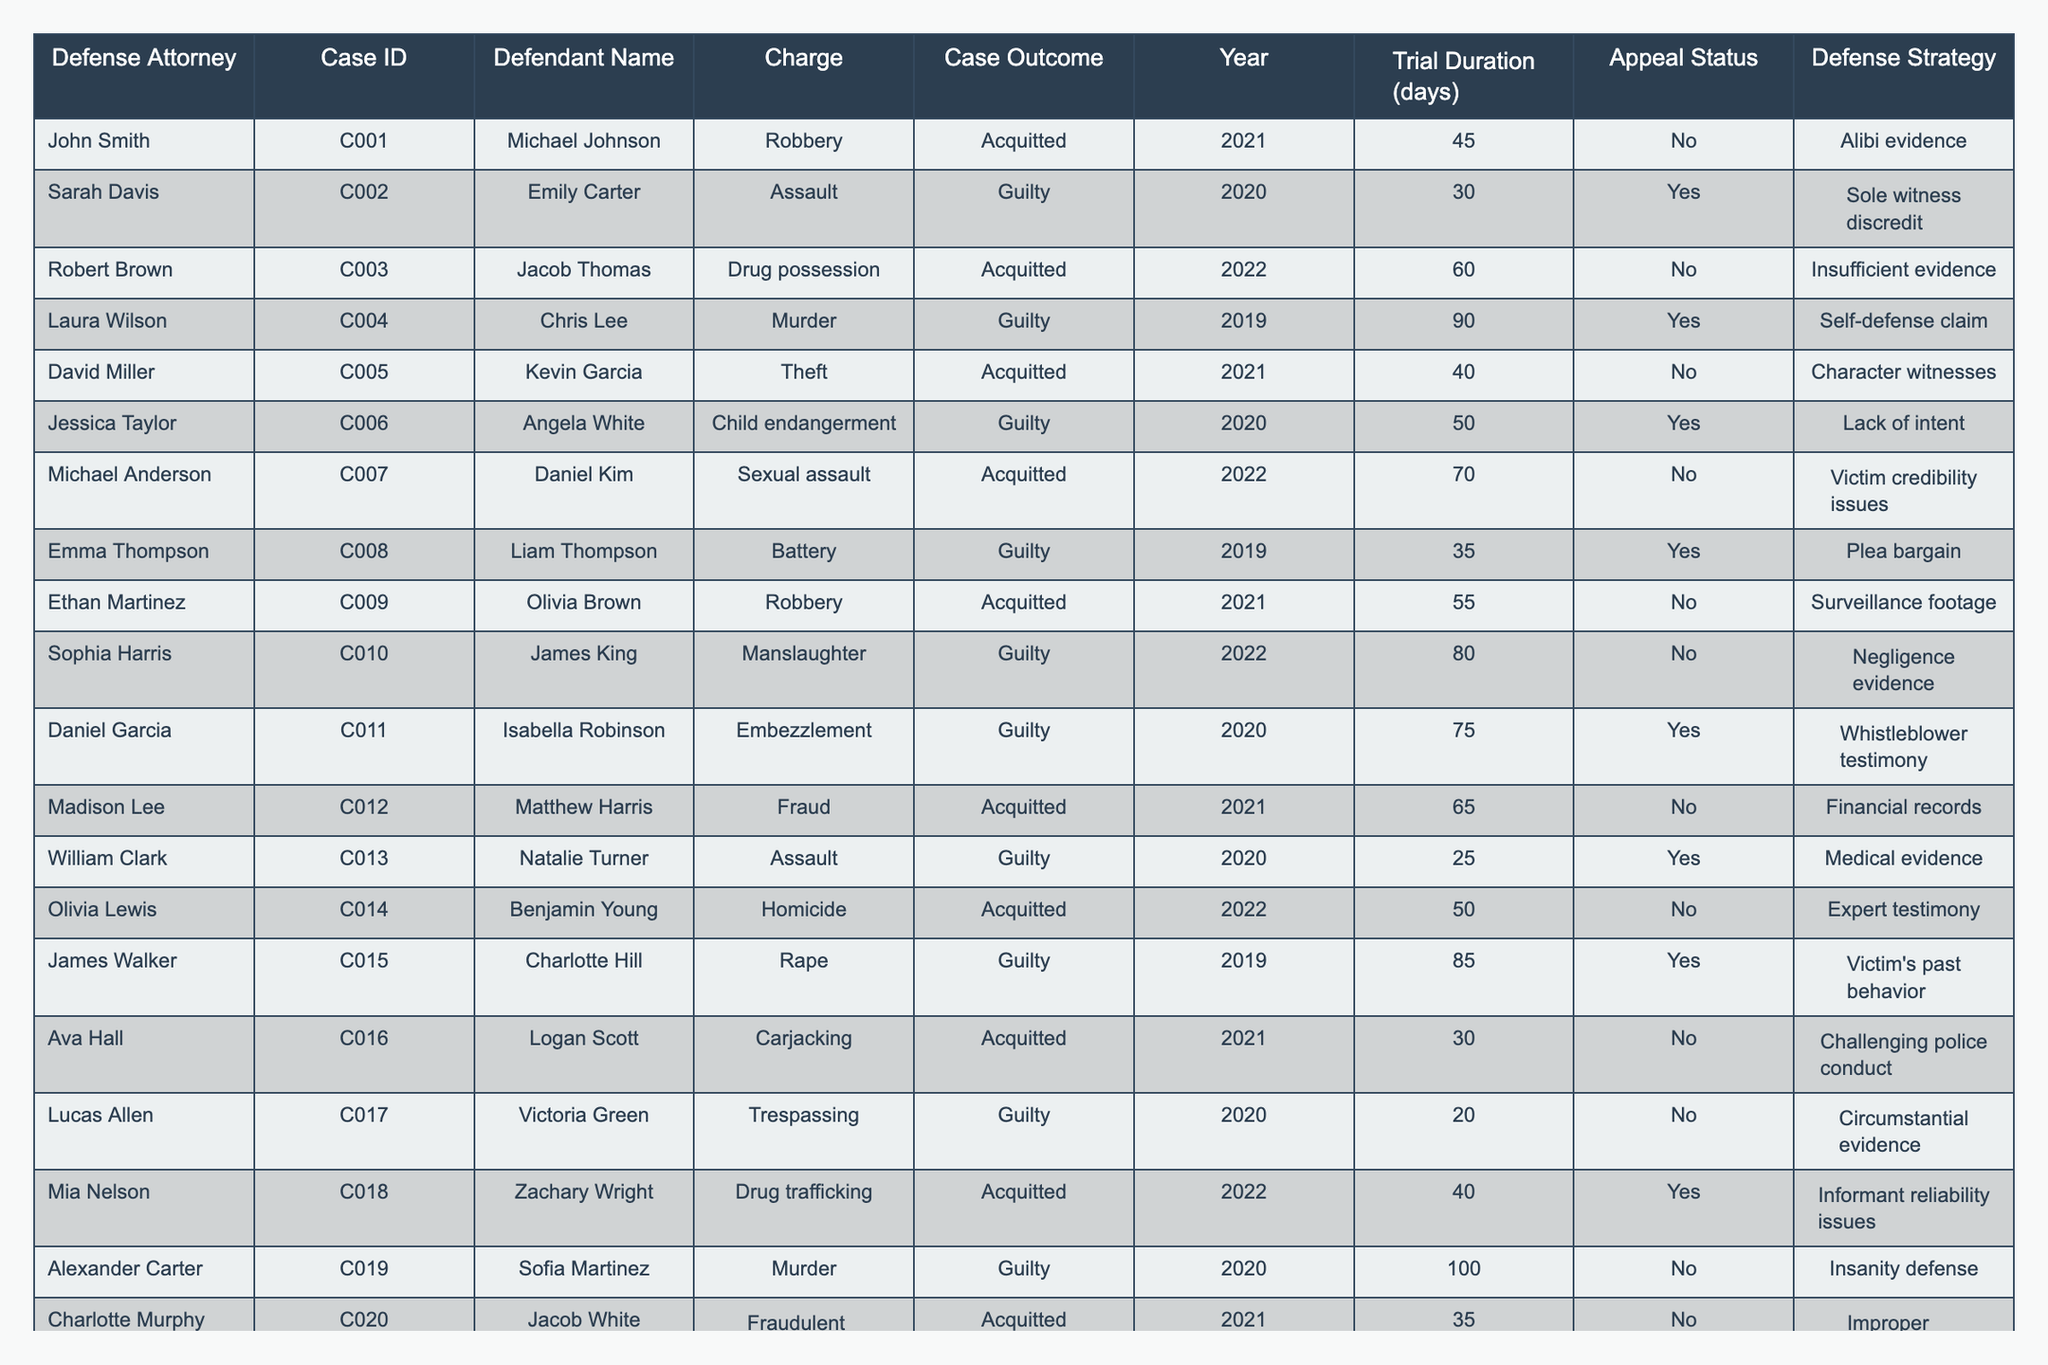What is the outcome of Case ID C001? The table shows that Case ID C001, which is associated with Michael Johnson, has an outcome of Acquitted.
Answer: Acquitted How many cases resulted in a Guilty outcome? By counting the rows in the table with a 'Guilty' outcome, we find there are 8 cases that resulted in a Guilty verdict.
Answer: 8 Which defense attorney won the most cases? Looking at the Acquitted outcomes in the table, John Smith, Robert Brown, David Miller, Michael Anderson, Ethan Martinez, Madison Lee, Olivia Lewis, and Charlotte Murphy all won cases. Counting these shows that John Smith, Robert Brown, and Michael Anderson had a unique win for the Acquitted outcome.
Answer: No single attorney won the most cases What is the average trial duration for Guilty cases? To find the average, we need to sum the trial durations of all Guilty cases (30 + 90 + 50 + 75 + 25 + 85 + 100) and divide by the number of Guilty cases (8). This gives us a total of 455 days, which when divided by 8 results in an average of 56.875 days.
Answer: Approximately 56.88 Is there a case with both an appeal and an Acquitted outcome? Scanning through the table, we see that there are no cases where the Appeal Status is 'Yes' and the Case Outcome is 'Acquitted'.
Answer: No What fraction of cases were Acquitted? There are 12 cases in total (8 Guilty and 12 Acquitted). The fraction of cases Acquitted can be calculated as 12 out of 20, which simplifies to 3/5. Therefore, 3/5 of the cases were Acquitted.
Answer: 3/5 Which defense strategy led to the most Guilty outcomes? Reviewing the table, we can see strategies linked to Guilty outcomes like 'Sole witness discredit', 'Lack of intent', 'Medical evidence', and others. However, the specific number of cases per strategy is not determined from the table without counting.
Answer: No single strategy stood out Was there a Guilty outcome in 2021? By examining the Year column for Guilty outcomes, we identify there are no Guilty cases recorded in 2021. Thus, the answer is based on verification of years with 'Guilty' status.
Answer: No What is the total number of Acquitted cases in 2022? From the table, there are three Acquitted cases marked in the year 2022, which are C003, C007, and C018.
Answer: 3 Which defendant has the highest trial duration among the Guilty cases? To find this, we review the trial durations of the Guilty outcomes and identify that Alexander Carter's case took 100 days, making it the longest among the Guilty cases.
Answer: 100 days 